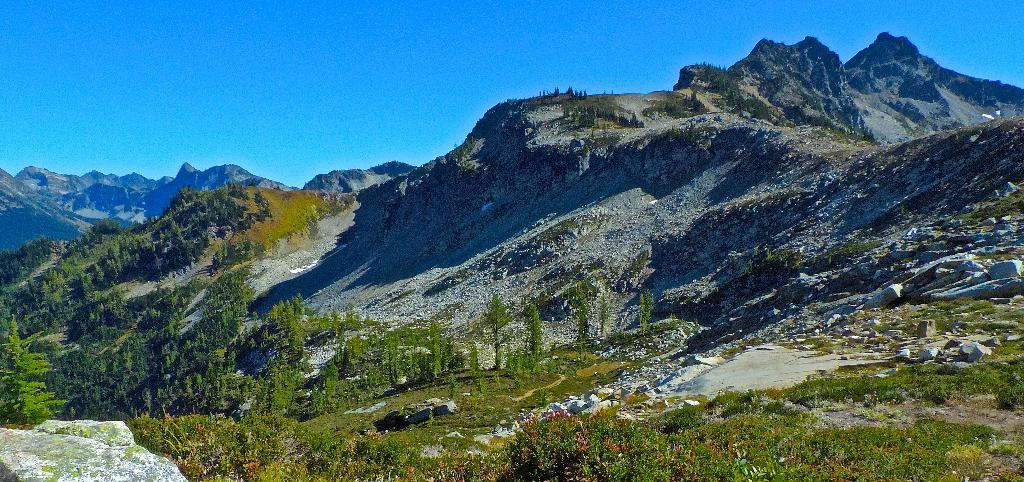What type of natural elements can be seen in the image? There are trees and mountains visible in the image. What other objects can be seen in the image? There are stones in the image. What is visible in the background of the image? The sky is visible in the background of the image. How many beggars can be seen resting under the trees in the image? There are no beggars or any indication of resting in the image; it features trees, mountains, stones, and the sky. 